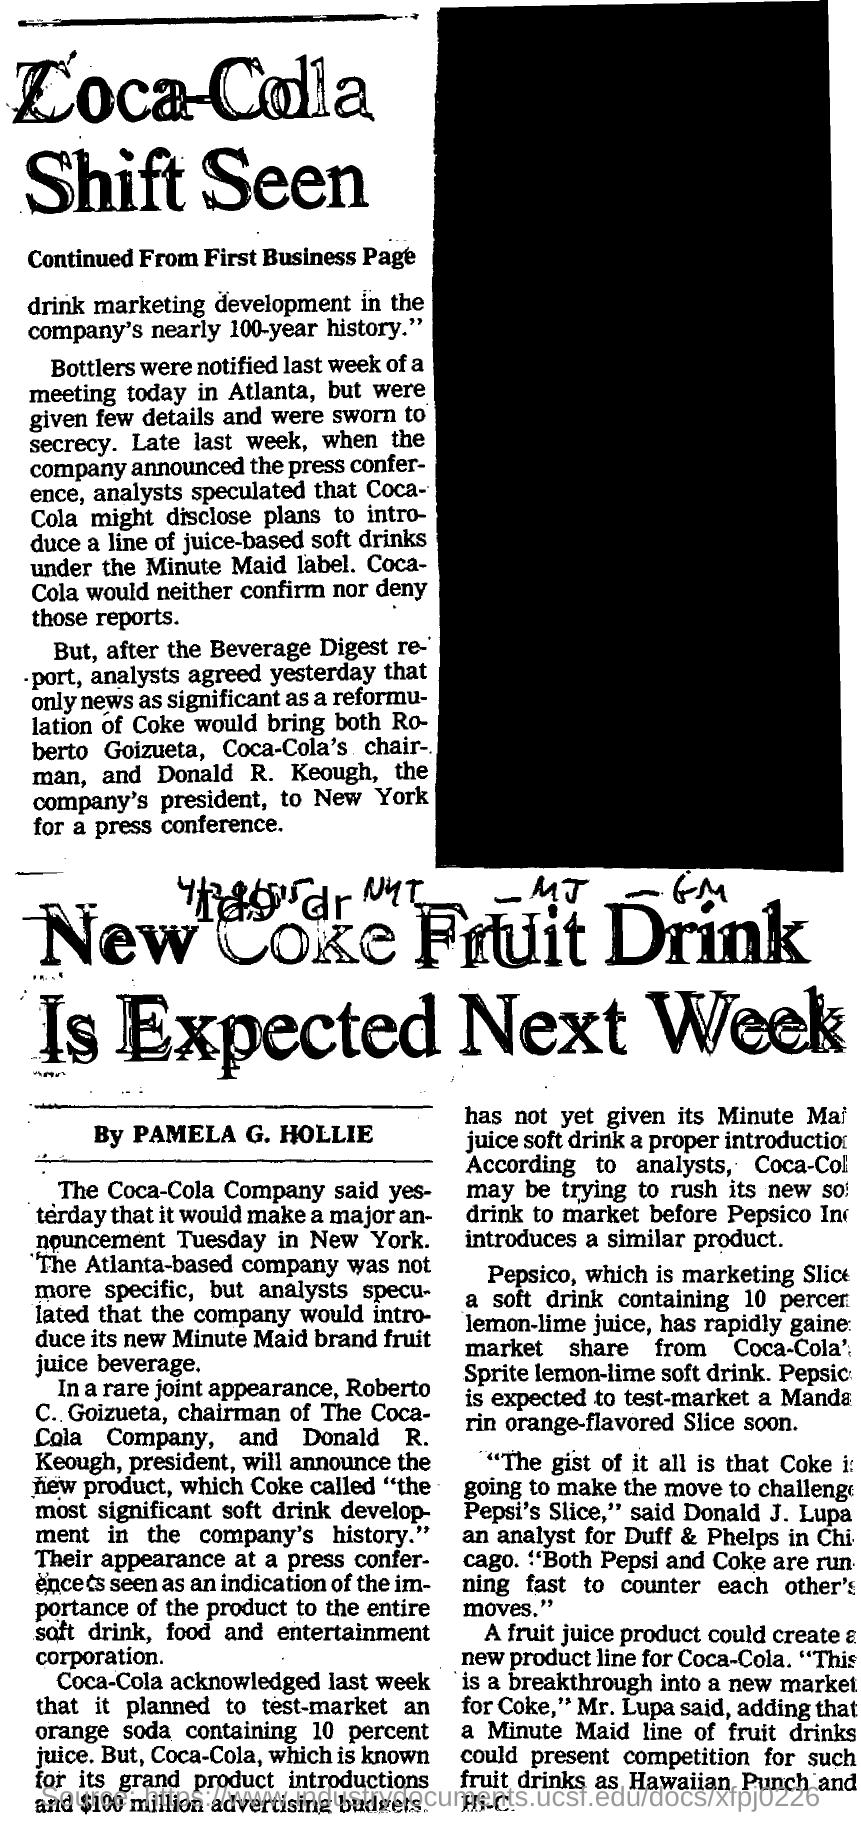Where was the meeting held?
Offer a very short reply. Atlanta. When will the announcement be held?
Provide a succinct answer. Tuesday. Who is the chairman of Coca-Cola company?
Offer a terse response. Roberto C. Goizueta. 